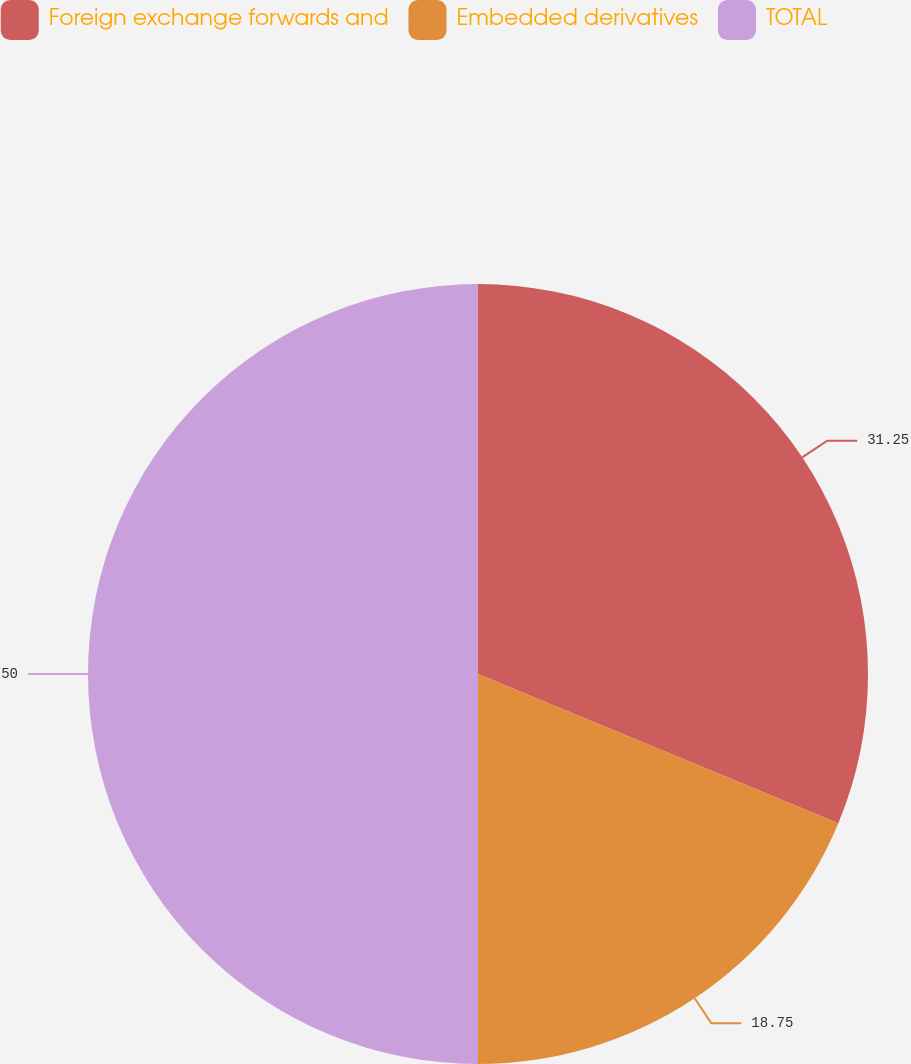Convert chart to OTSL. <chart><loc_0><loc_0><loc_500><loc_500><pie_chart><fcel>Foreign exchange forwards and<fcel>Embedded derivatives<fcel>TOTAL<nl><fcel>31.25%<fcel>18.75%<fcel>50.0%<nl></chart> 